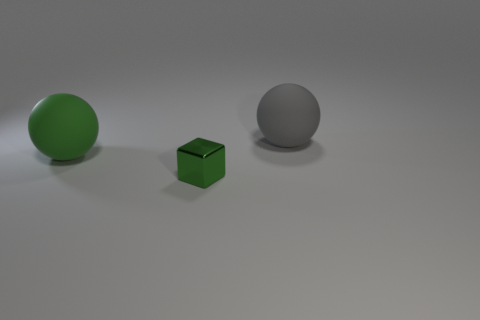Add 3 small blue matte spheres. How many objects exist? 6 Subtract all spheres. How many objects are left? 1 Add 2 big green blocks. How many big green blocks exist? 2 Subtract 0 red blocks. How many objects are left? 3 Subtract all big gray balls. Subtract all big spheres. How many objects are left? 0 Add 2 small cubes. How many small cubes are left? 3 